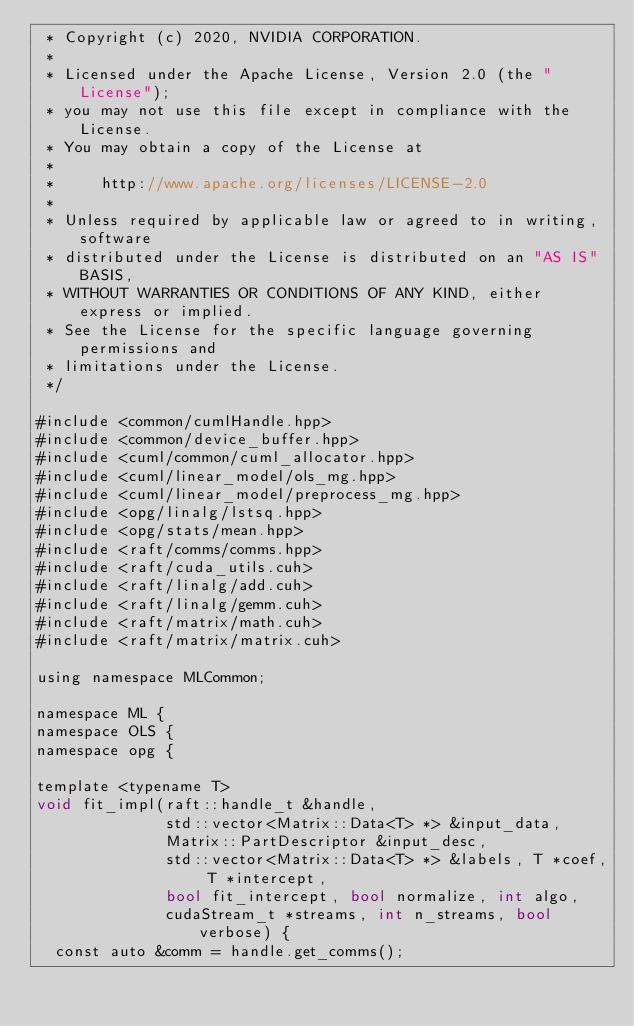<code> <loc_0><loc_0><loc_500><loc_500><_Cuda_> * Copyright (c) 2020, NVIDIA CORPORATION.
 *
 * Licensed under the Apache License, Version 2.0 (the "License");
 * you may not use this file except in compliance with the License.
 * You may obtain a copy of the License at
 *
 *     http://www.apache.org/licenses/LICENSE-2.0
 *
 * Unless required by applicable law or agreed to in writing, software
 * distributed under the License is distributed on an "AS IS" BASIS,
 * WITHOUT WARRANTIES OR CONDITIONS OF ANY KIND, either express or implied.
 * See the License for the specific language governing permissions and
 * limitations under the License.
 */

#include <common/cumlHandle.hpp>
#include <common/device_buffer.hpp>
#include <cuml/common/cuml_allocator.hpp>
#include <cuml/linear_model/ols_mg.hpp>
#include <cuml/linear_model/preprocess_mg.hpp>
#include <opg/linalg/lstsq.hpp>
#include <opg/stats/mean.hpp>
#include <raft/comms/comms.hpp>
#include <raft/cuda_utils.cuh>
#include <raft/linalg/add.cuh>
#include <raft/linalg/gemm.cuh>
#include <raft/matrix/math.cuh>
#include <raft/matrix/matrix.cuh>

using namespace MLCommon;

namespace ML {
namespace OLS {
namespace opg {

template <typename T>
void fit_impl(raft::handle_t &handle,
              std::vector<Matrix::Data<T> *> &input_data,
              Matrix::PartDescriptor &input_desc,
              std::vector<Matrix::Data<T> *> &labels, T *coef, T *intercept,
              bool fit_intercept, bool normalize, int algo,
              cudaStream_t *streams, int n_streams, bool verbose) {
  const auto &comm = handle.get_comms();</code> 